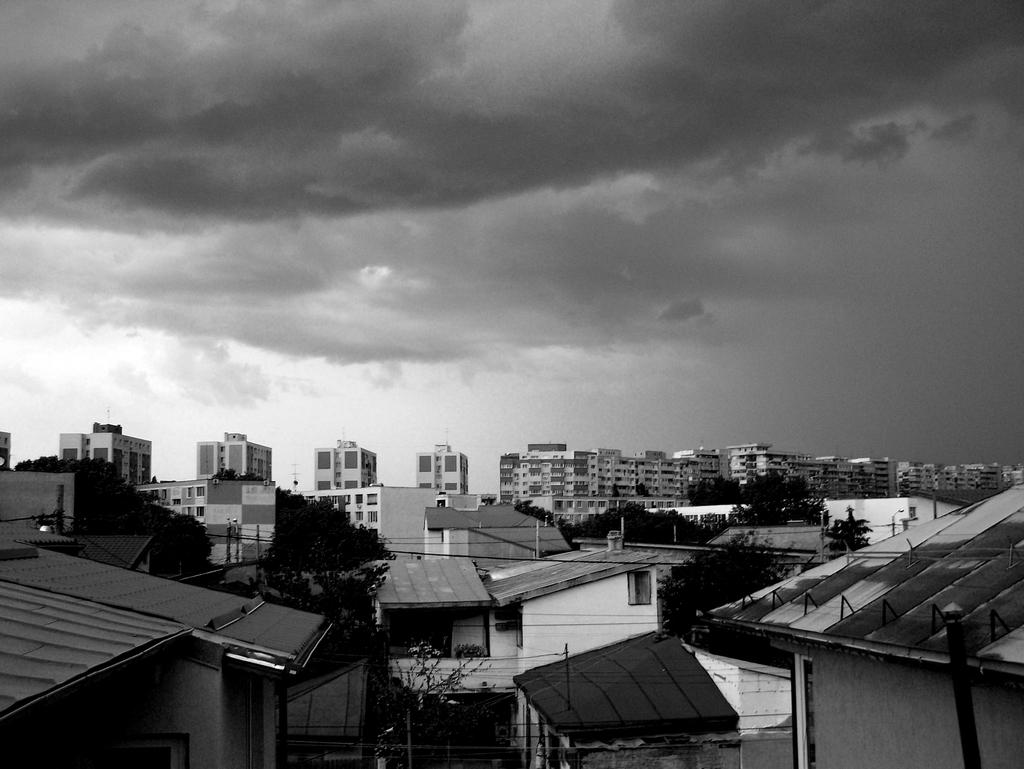What is the color scheme of the image? The image is black and white. What type of structures can be seen in the image? There are buildings in the image. What other objects are present in the image besides buildings? There are poles, trees, wires, and the sky is visible in the image. What can be seen in the sky in the image? Clouds are present in the sky. What type of egg is being used as a doorstop in the image? There is no egg present in the image, let alone being used as a doorstop. What is the purpose of the cat in the image? There is no cat present in the image, so it is impossible to determine its purpose. 